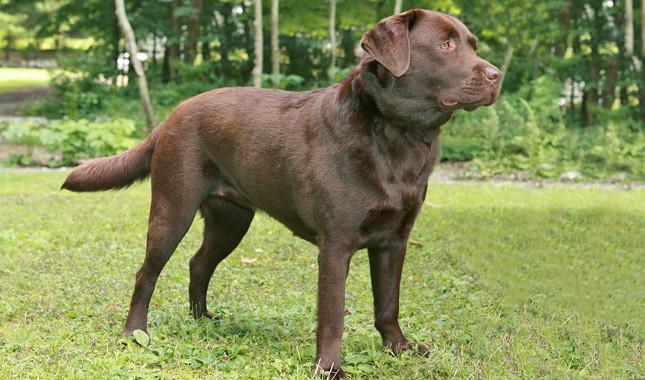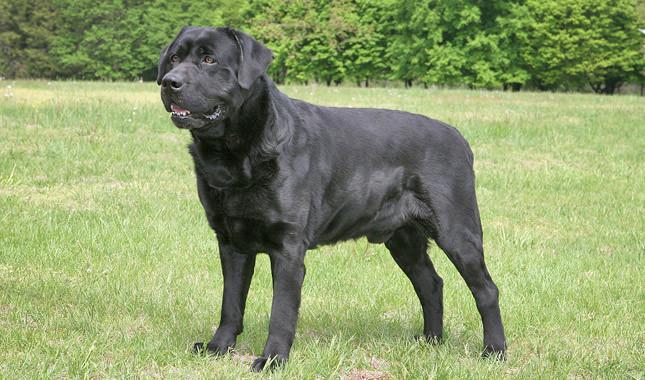The first image is the image on the left, the second image is the image on the right. Examine the images to the left and right. Is the description "There are at least four dogs." accurate? Answer yes or no. No. 